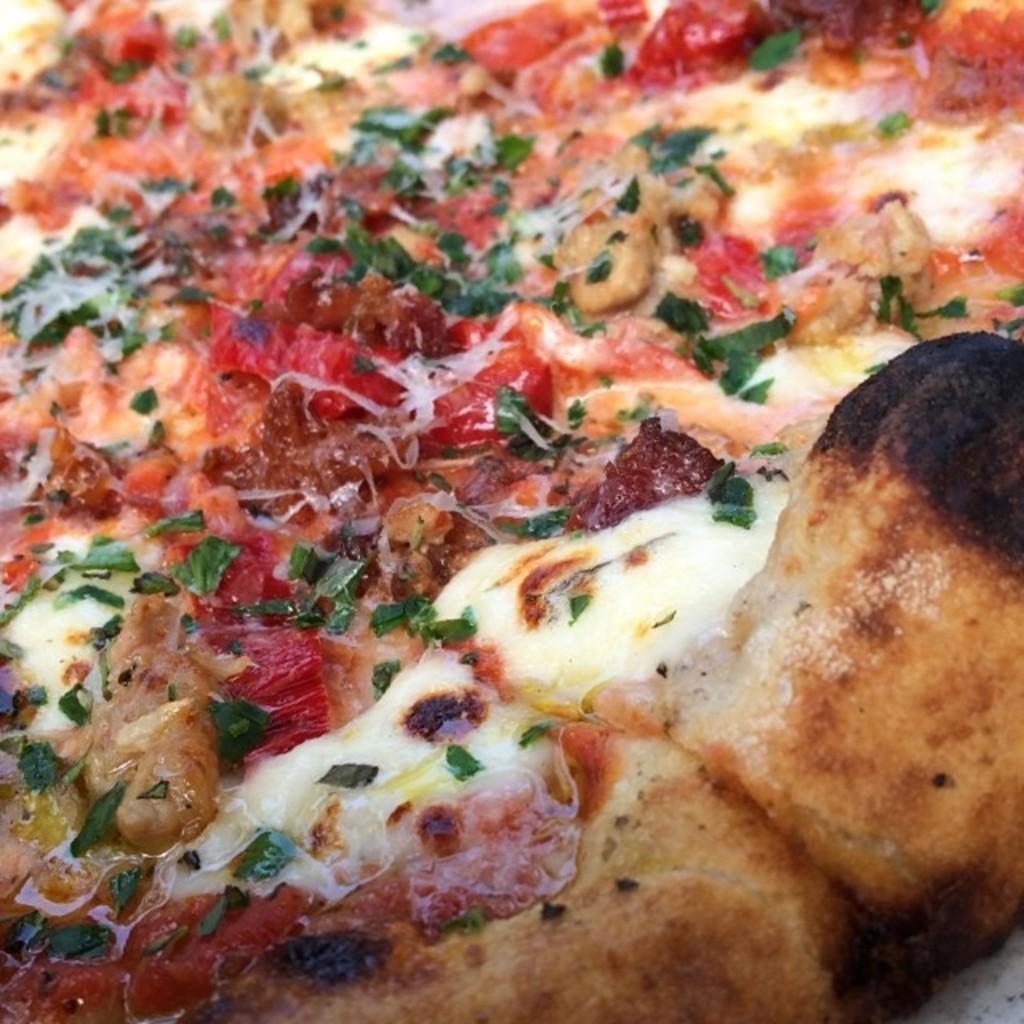What type of food is the main subject of the image? There is a pizza in the image. What are some of the toppings on the pizza? The pizza has cheese and sauce on it, and there are other items sprinkled over it. What type of soup is being served in the image? There is no soup present in the image; it features a pizza with various toppings. What type of cabbage is visible on the pizza in the image? There is no cabbage visible on the pizza in the image. 